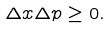<formula> <loc_0><loc_0><loc_500><loc_500>\Delta x \Delta p \geq 0 .</formula> 